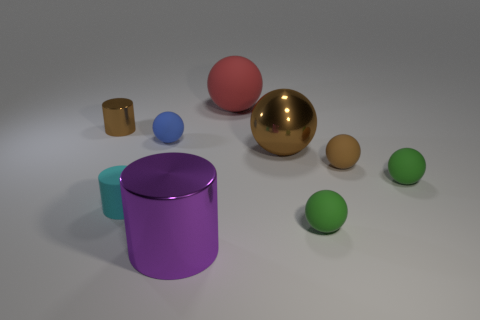Subtract all yellow spheres. Subtract all gray cubes. How many spheres are left? 6 Subtract all blue balls. How many green cylinders are left? 0 Add 9 tiny objects. How many browns exist? 0 Subtract all purple cylinders. Subtract all red cylinders. How many objects are left? 8 Add 6 small cyan objects. How many small cyan objects are left? 7 Add 8 tiny gray things. How many tiny gray things exist? 8 Add 1 small brown cylinders. How many objects exist? 10 Subtract all blue spheres. How many spheres are left? 5 Subtract all cyan rubber cylinders. How many cylinders are left? 2 Subtract 1 blue balls. How many objects are left? 8 